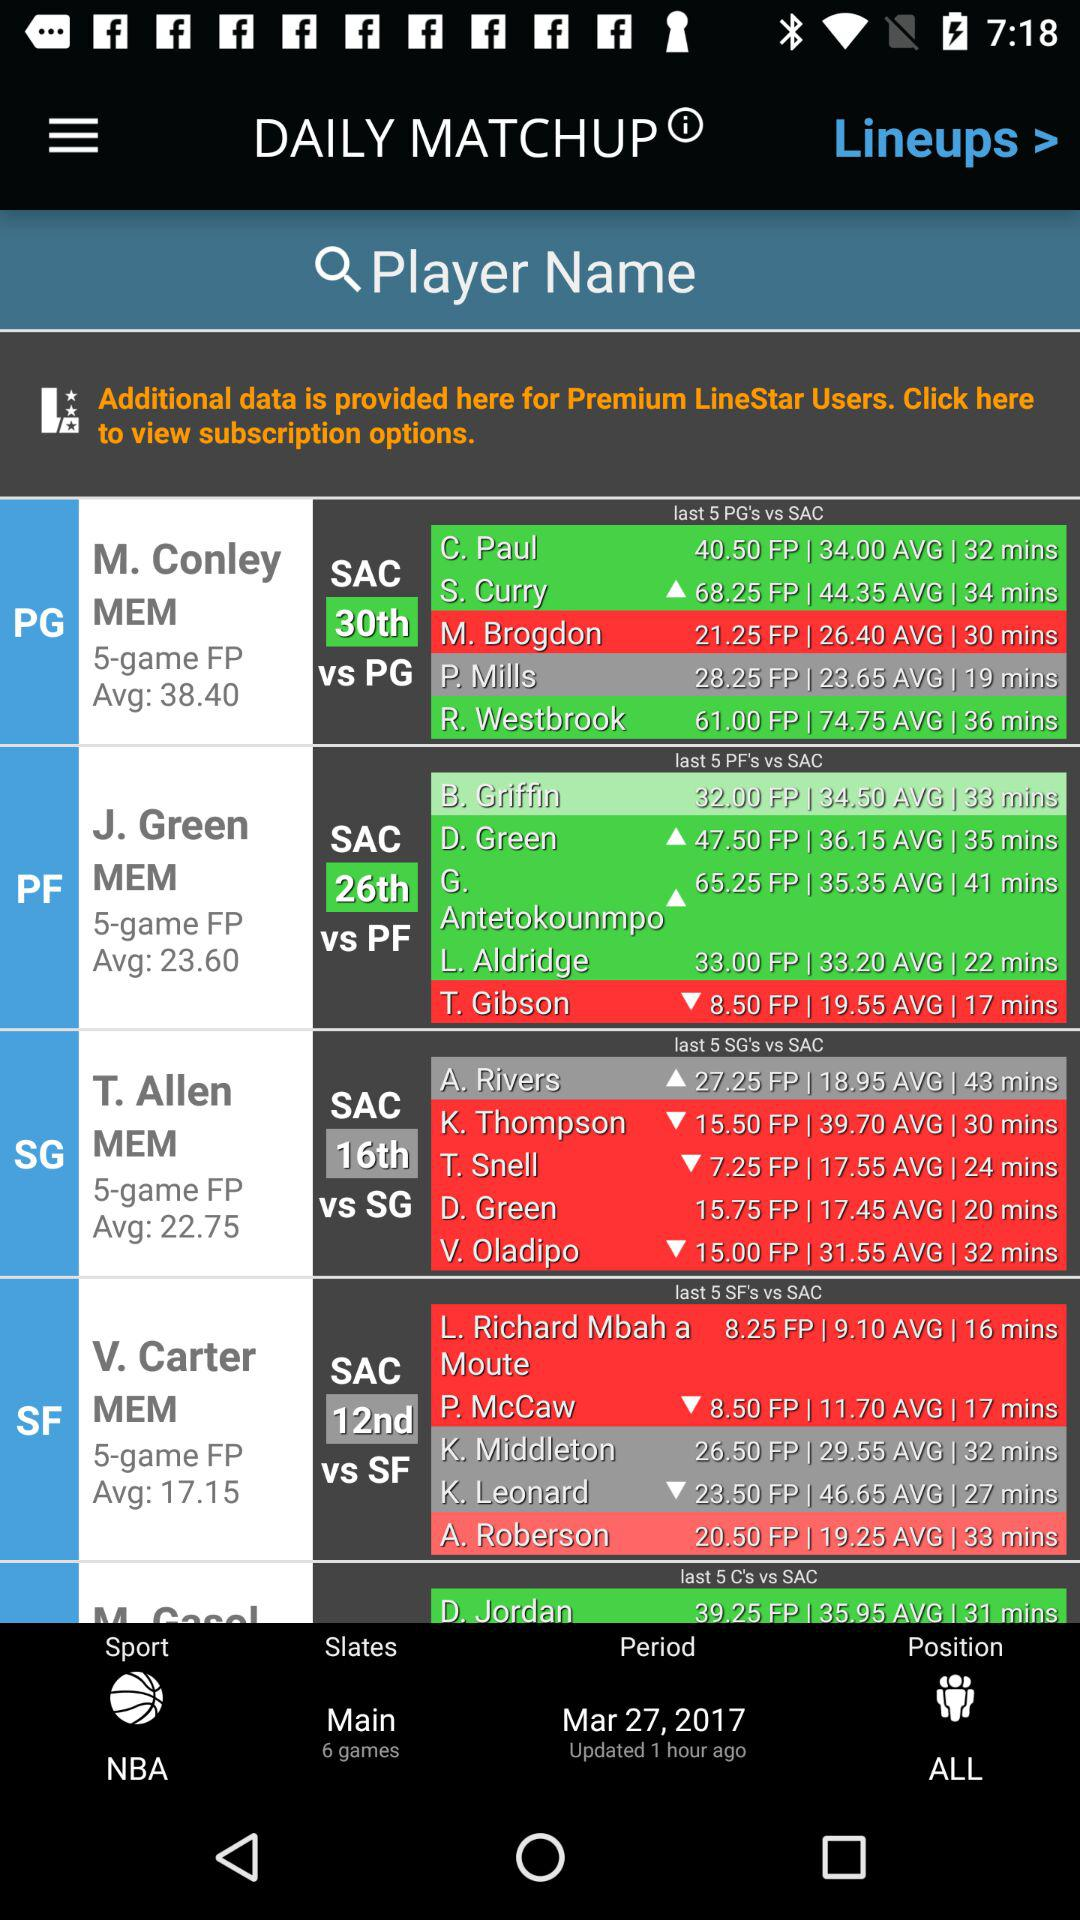What is the average score of V. Carter? The average score is 17.15. 